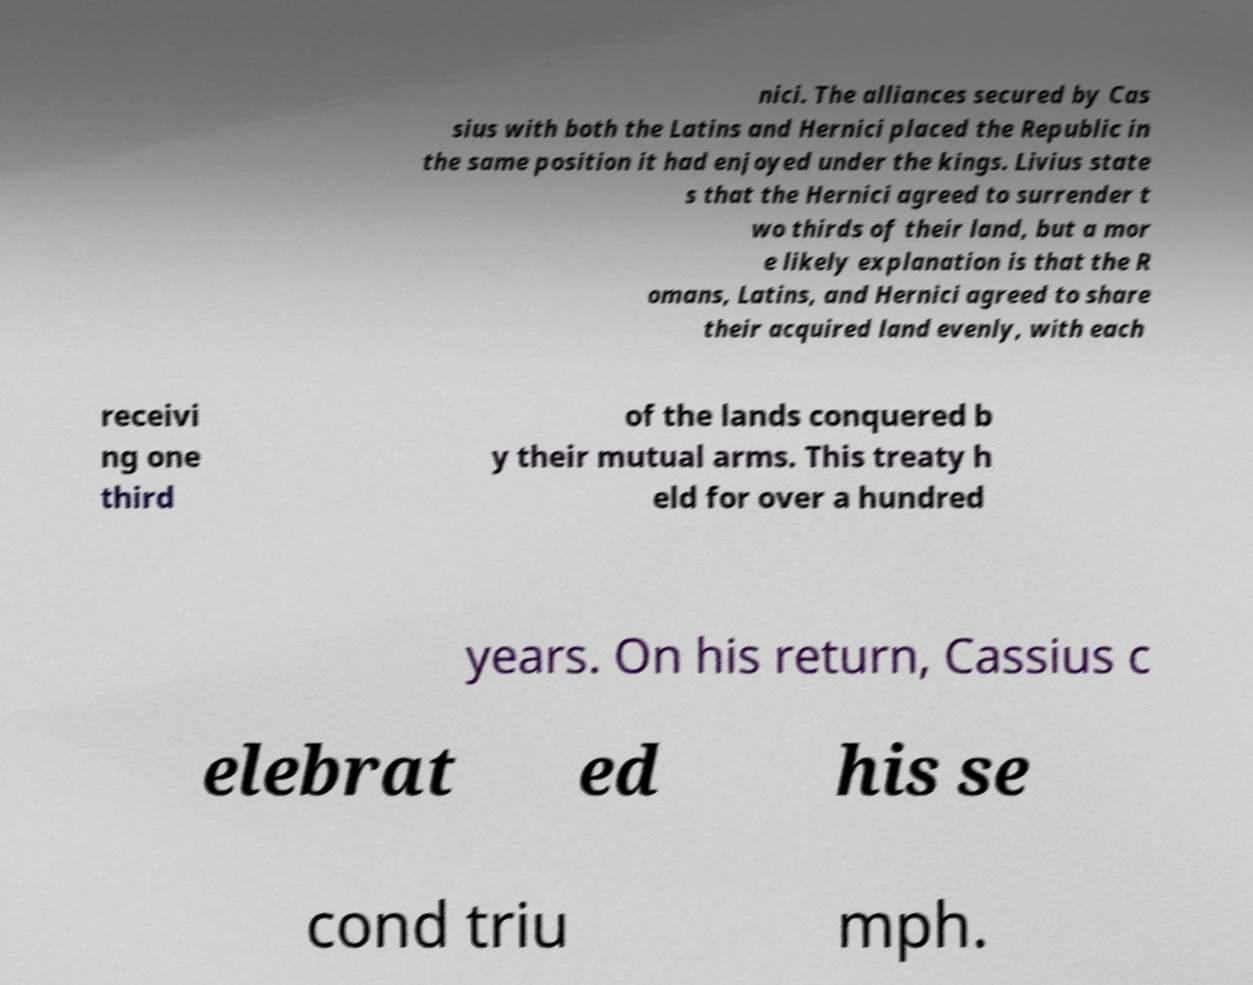Can you read and provide the text displayed in the image?This photo seems to have some interesting text. Can you extract and type it out for me? nici. The alliances secured by Cas sius with both the Latins and Hernici placed the Republic in the same position it had enjoyed under the kings. Livius state s that the Hernici agreed to surrender t wo thirds of their land, but a mor e likely explanation is that the R omans, Latins, and Hernici agreed to share their acquired land evenly, with each receivi ng one third of the lands conquered b y their mutual arms. This treaty h eld for over a hundred years. On his return, Cassius c elebrat ed his se cond triu mph. 